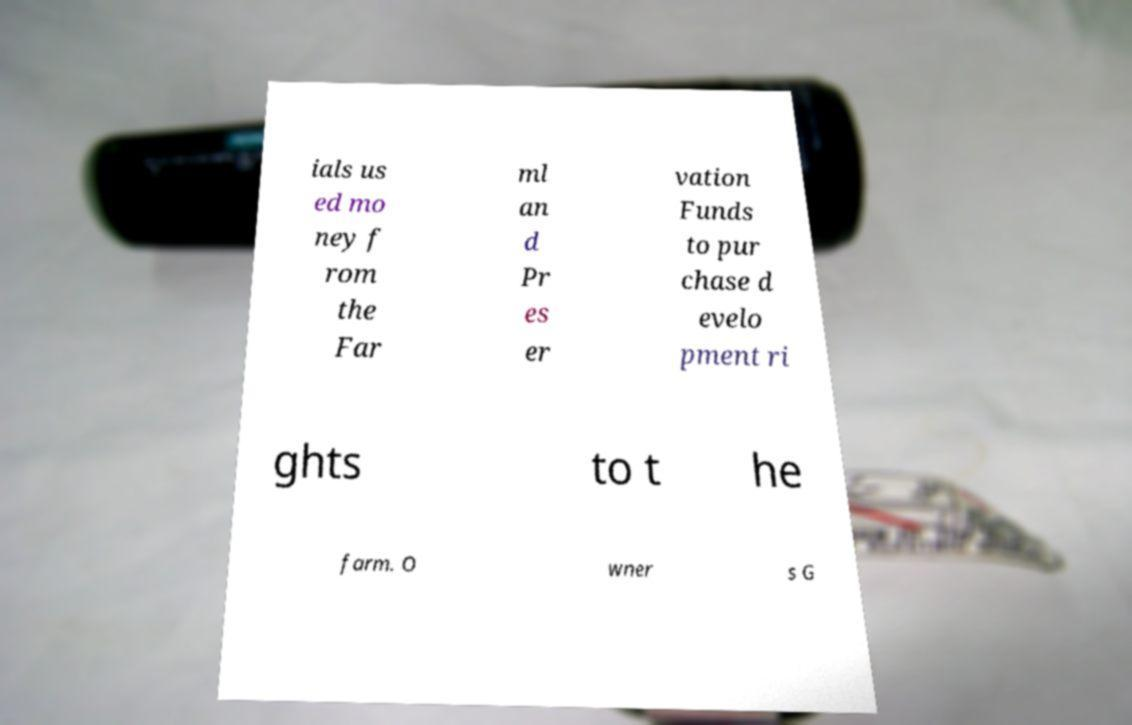Please identify and transcribe the text found in this image. ials us ed mo ney f rom the Far ml an d Pr es er vation Funds to pur chase d evelo pment ri ghts to t he farm. O wner s G 